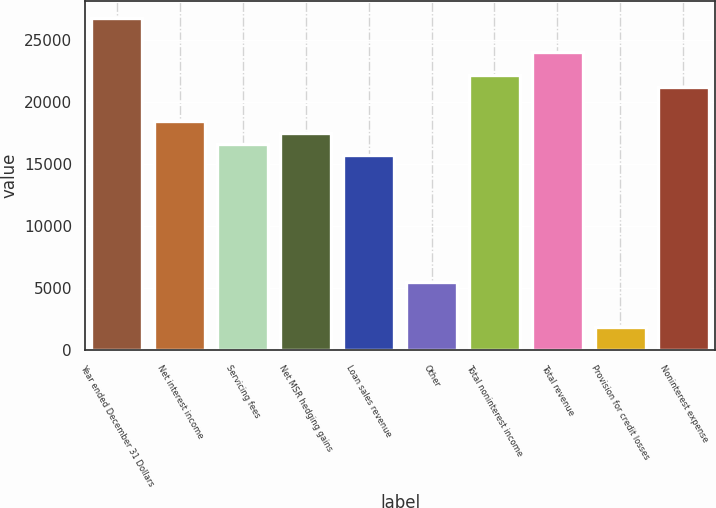Convert chart. <chart><loc_0><loc_0><loc_500><loc_500><bar_chart><fcel>Year ended December 31 Dollars<fcel>Net interest income<fcel>Servicing fees<fcel>Net MSR hedging gains<fcel>Loan sales revenue<fcel>Other<fcel>Total noninterest income<fcel>Total revenue<fcel>Provision for credit losses<fcel>Noninterest expense<nl><fcel>26814.4<fcel>18493<fcel>16643.8<fcel>17568.4<fcel>15719.2<fcel>5548.6<fcel>22191.4<fcel>24040.6<fcel>1850.2<fcel>21266.8<nl></chart> 